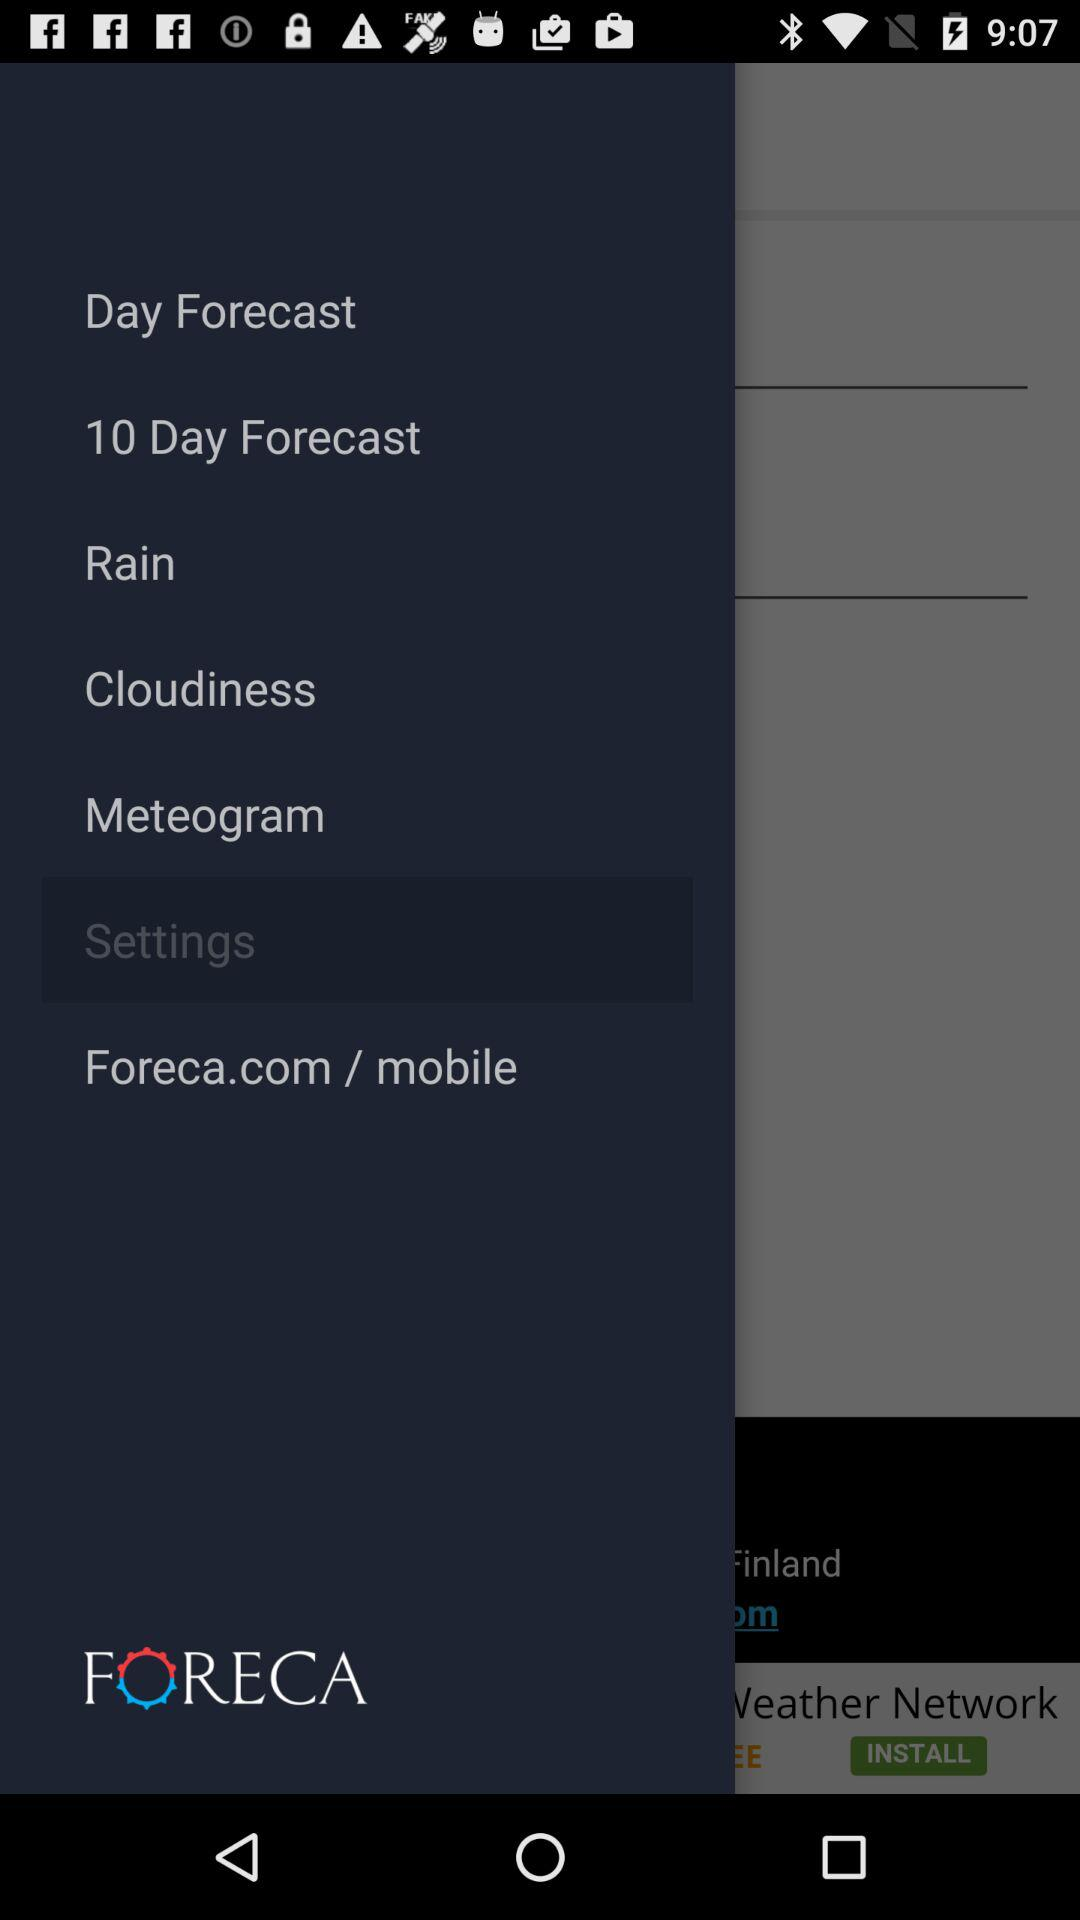What is the name of the application? The name of the application is "FORECA". 